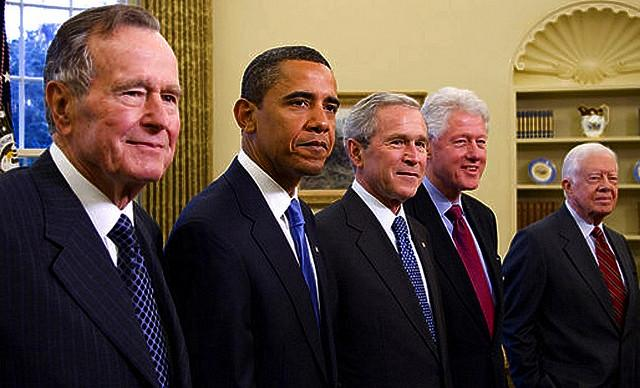Who is the second man from the left?

Choices:
A) barak obama
B) ronald reagan
C) ben franklin
D) george bush barak obama 